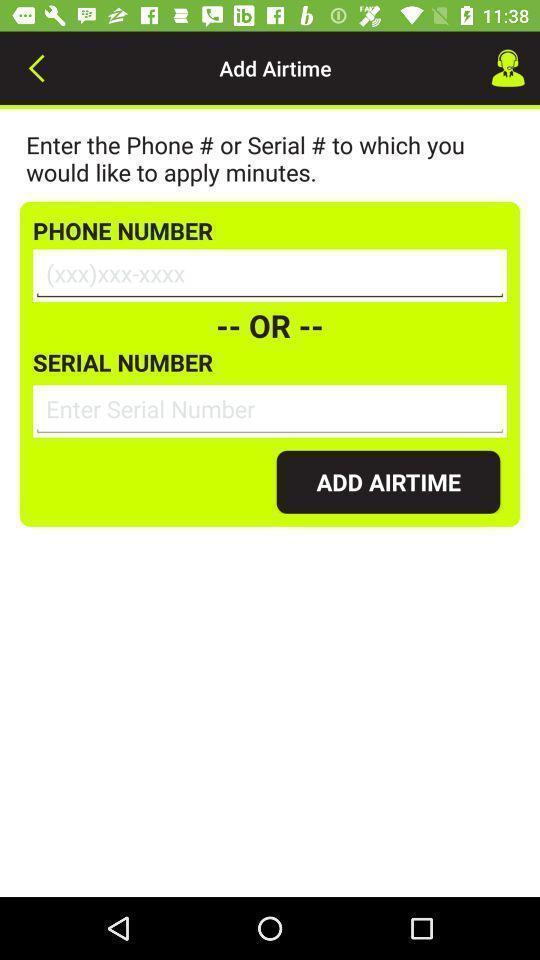Give me a summary of this screen capture. Page to add phone number for an app. 